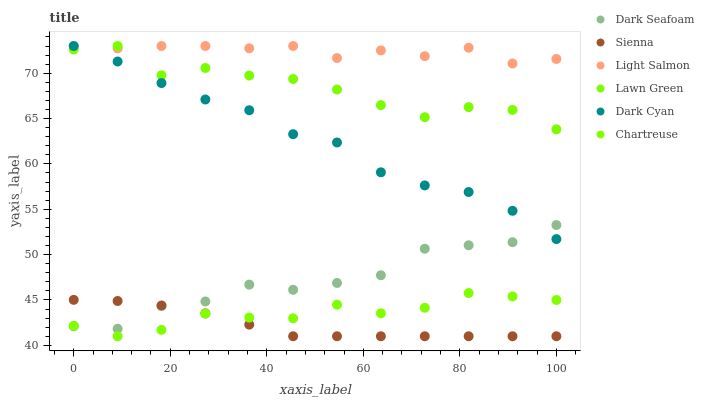Does Sienna have the minimum area under the curve?
Answer yes or no. Yes. Does Light Salmon have the maximum area under the curve?
Answer yes or no. Yes. Does Chartreuse have the minimum area under the curve?
Answer yes or no. No. Does Chartreuse have the maximum area under the curve?
Answer yes or no. No. Is Sienna the smoothest?
Answer yes or no. Yes. Is Lawn Green the roughest?
Answer yes or no. Yes. Is Light Salmon the smoothest?
Answer yes or no. No. Is Light Salmon the roughest?
Answer yes or no. No. Does Chartreuse have the lowest value?
Answer yes or no. Yes. Does Light Salmon have the lowest value?
Answer yes or no. No. Does Dark Cyan have the highest value?
Answer yes or no. Yes. Does Chartreuse have the highest value?
Answer yes or no. No. Is Chartreuse less than Lawn Green?
Answer yes or no. Yes. Is Dark Cyan greater than Sienna?
Answer yes or no. Yes. Does Chartreuse intersect Sienna?
Answer yes or no. Yes. Is Chartreuse less than Sienna?
Answer yes or no. No. Is Chartreuse greater than Sienna?
Answer yes or no. No. Does Chartreuse intersect Lawn Green?
Answer yes or no. No. 